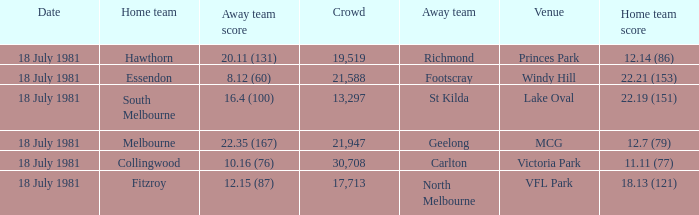What was the away team that played against Fitzroy? North Melbourne. 